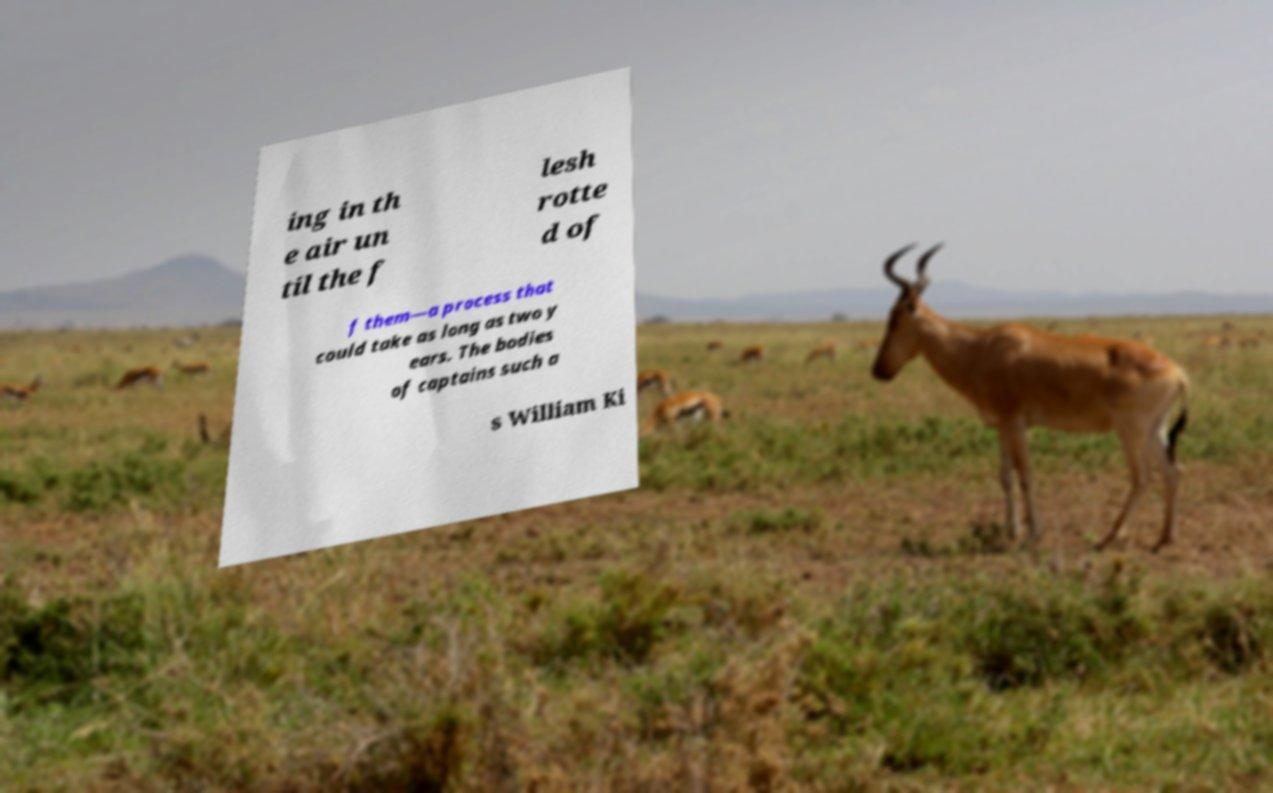Please read and relay the text visible in this image. What does it say? ing in th e air un til the f lesh rotte d of f them—a process that could take as long as two y ears. The bodies of captains such a s William Ki 